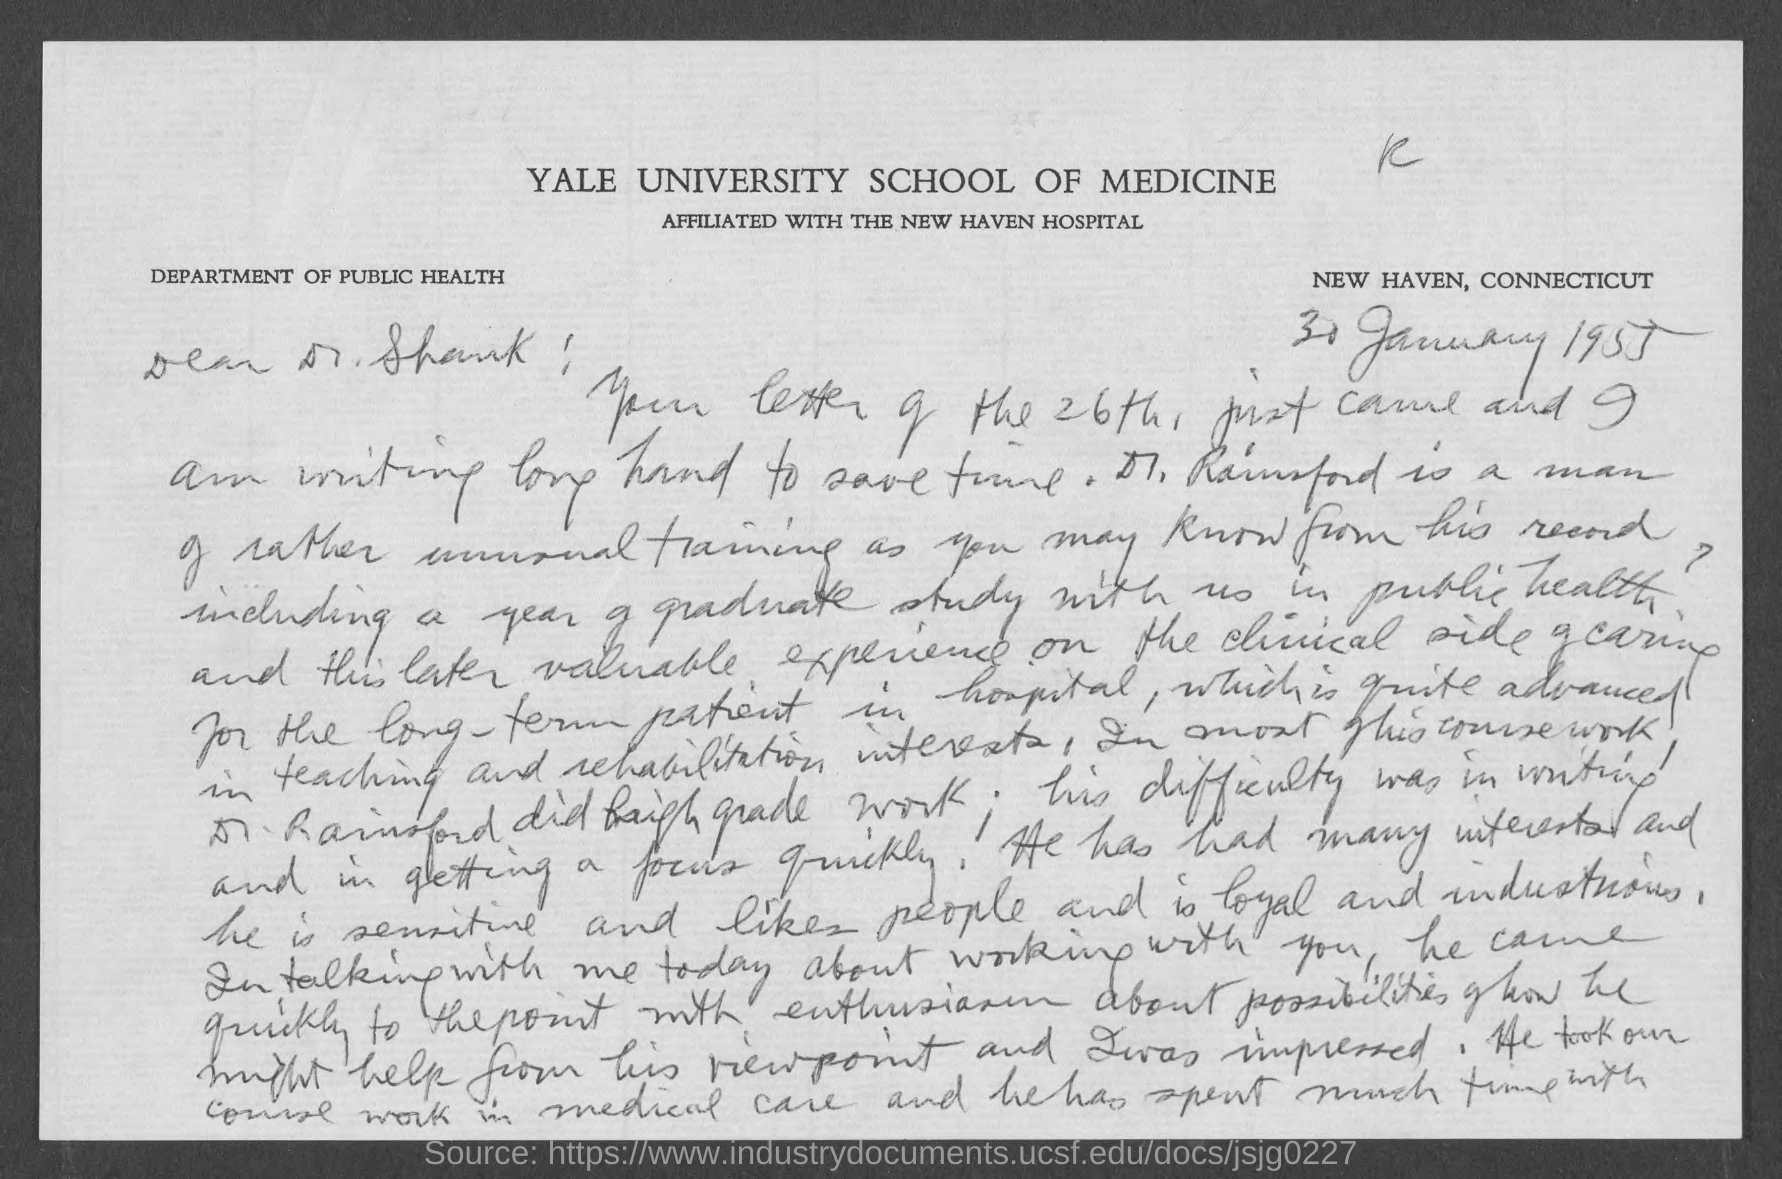Specify some key components in this picture. The letter is addressed to Dr. Shank. Yale University School of Medicine is affiliated with The New Haven Hospital. The date on the document is January 30, 1955. The location is in New Haven, Connecticut. 